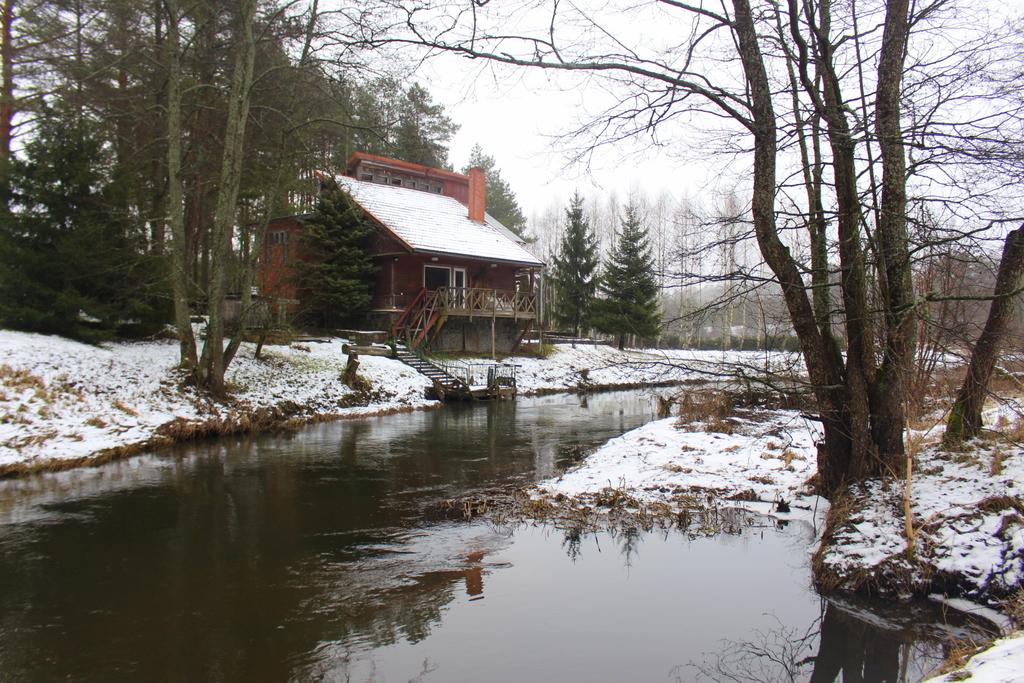What type of structure is present in the image? There is a house in the image. What is located at the bottom of the image? There is water at the bottom of the image. What is the weather like in the image? There is snow visible in the image, indicating a cold or snowy environment. What can be seen in the background of the image? There are trees in the background of the image. What is visible at the top of the image? The sky is visible at the top of the image. What type of punishment is being administered to the mountain in the image? There is no mountain present in the image, and therefore no punishment can be observed. What color is the pen used by the person in the image? There are no people or pens present in the image. 